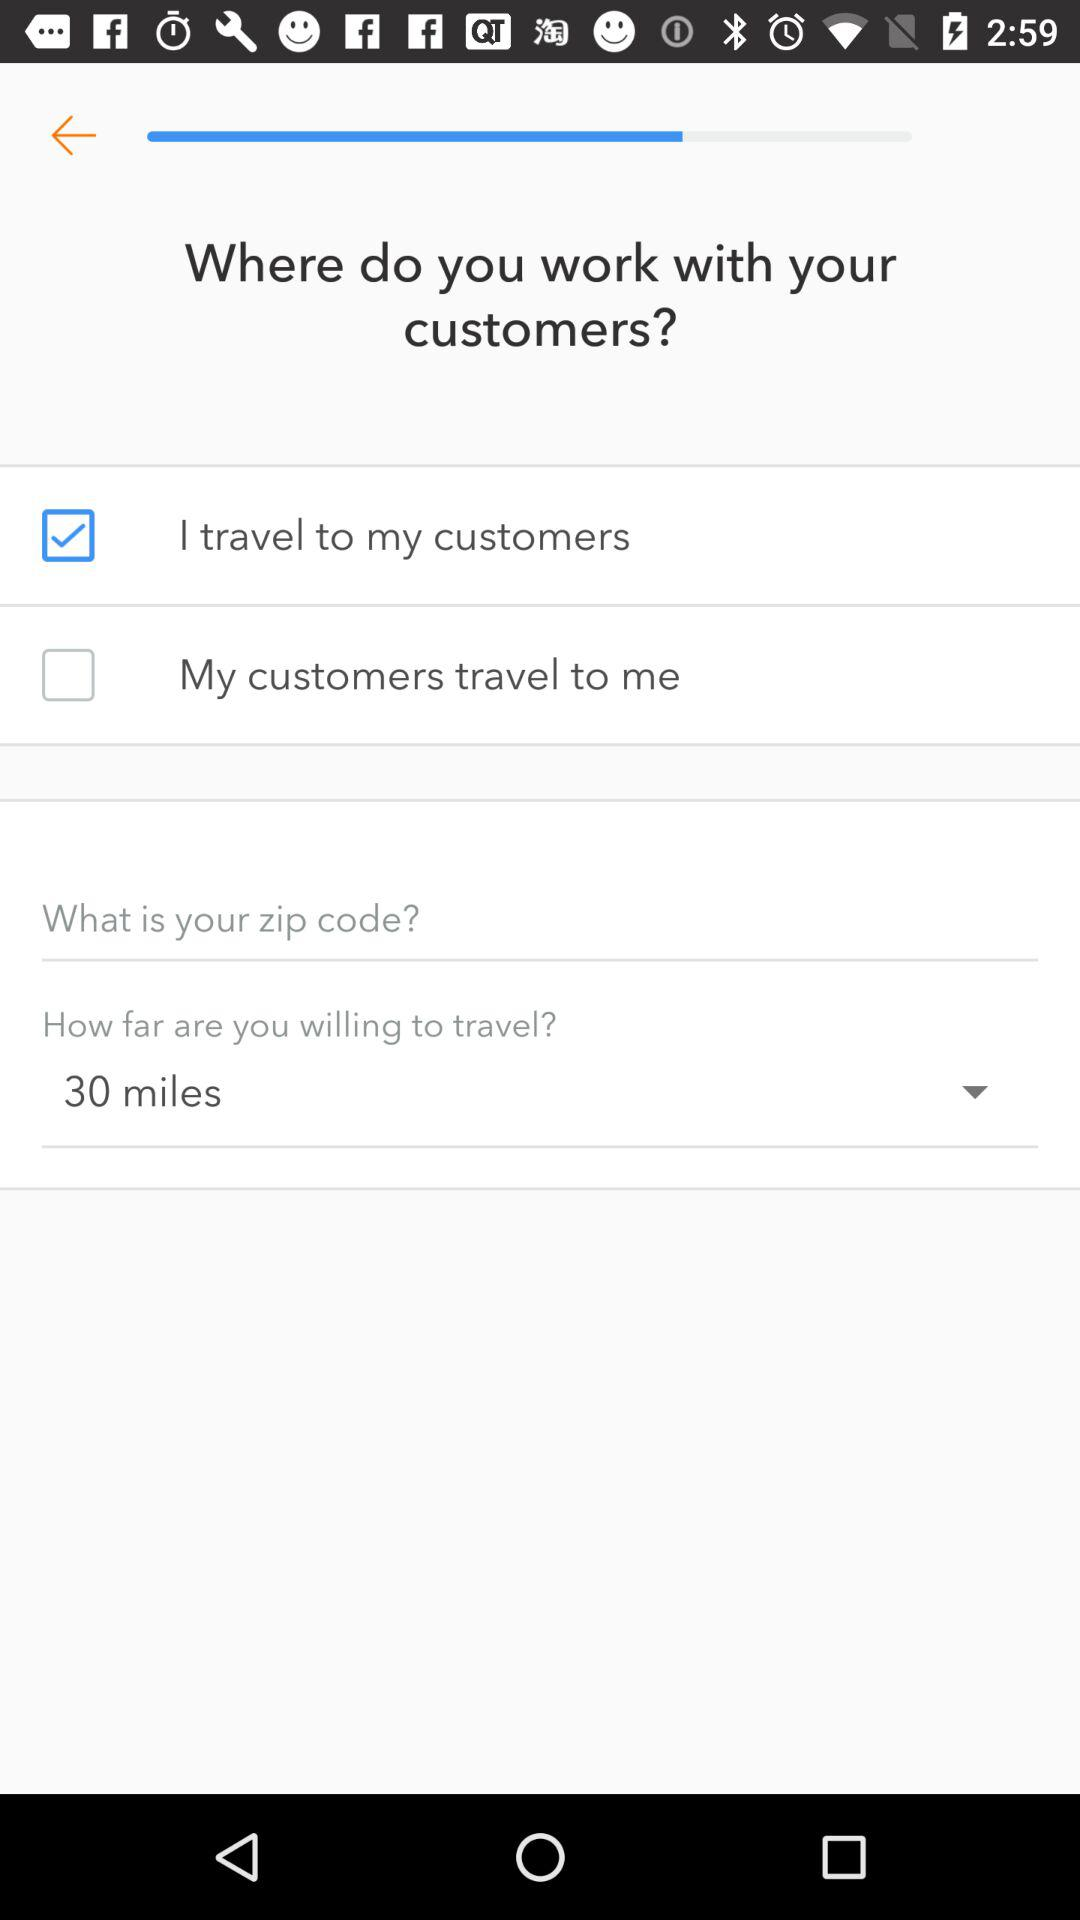How many checkboxes are there that allow the user to select their preference for working with customers?
Answer the question using a single word or phrase. 2 